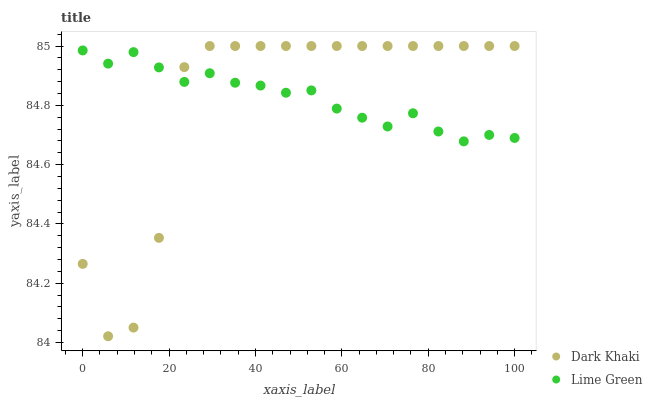Does Dark Khaki have the minimum area under the curve?
Answer yes or no. Yes. Does Lime Green have the maximum area under the curve?
Answer yes or no. Yes. Does Lime Green have the minimum area under the curve?
Answer yes or no. No. Is Lime Green the smoothest?
Answer yes or no. Yes. Is Dark Khaki the roughest?
Answer yes or no. Yes. Is Lime Green the roughest?
Answer yes or no. No. Does Dark Khaki have the lowest value?
Answer yes or no. Yes. Does Lime Green have the lowest value?
Answer yes or no. No. Does Dark Khaki have the highest value?
Answer yes or no. Yes. Does Lime Green have the highest value?
Answer yes or no. No. Does Lime Green intersect Dark Khaki?
Answer yes or no. Yes. Is Lime Green less than Dark Khaki?
Answer yes or no. No. Is Lime Green greater than Dark Khaki?
Answer yes or no. No. 